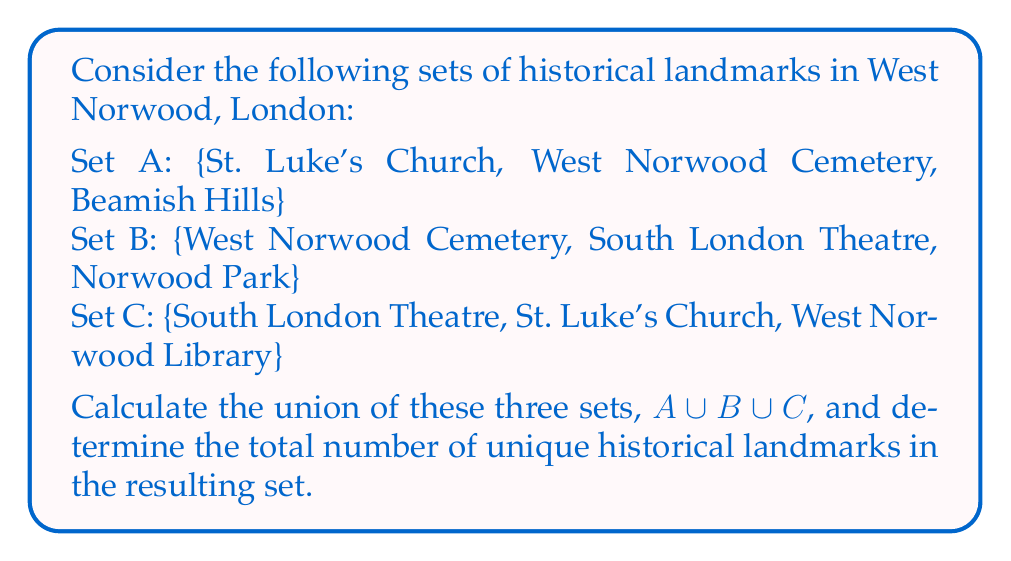Can you solve this math problem? To solve this problem, we need to follow these steps:

1. Identify all unique elements across the three sets.
2. Combine these elements into a single set (the union).
3. Count the number of elements in the resulting set.

Let's break it down:

1. Identifying unique elements:
   - Set A: St. Luke's Church, West Norwood Cemetery, Beamish Hills
   - Set B: West Norwood Cemetery, South London Theatre, Norwood Park
   - Set C: South London Theatre, St. Luke's Church, West Norwood Library

2. Combining into a single set (union):
   $A \cup B \cup C = \{$ St. Luke's Church, West Norwood Cemetery, Beamish Hills, South London Theatre, Norwood Park, West Norwood Library $\}$

   Note that we only list each element once, even if it appears in multiple original sets.

3. Counting the elements:
   The resulting set contains 6 unique elements.

Therefore, the union of sets A, B, and C contains 6 unique historical landmarks in West Norwood, London.
Answer: $|A \cup B \cup C| = 6$ 